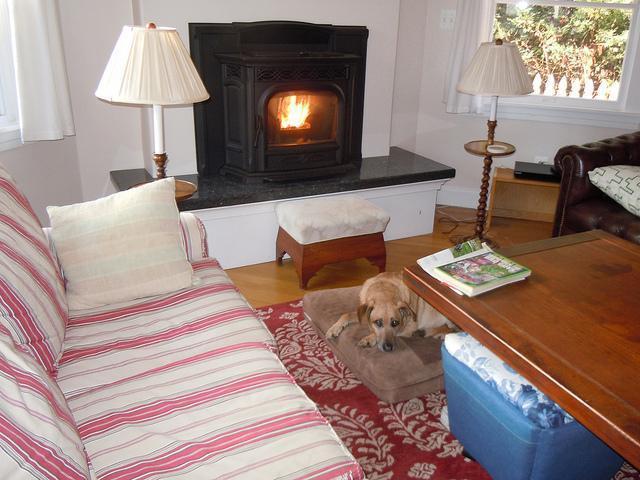How many couches are visible?
Give a very brief answer. 2. 